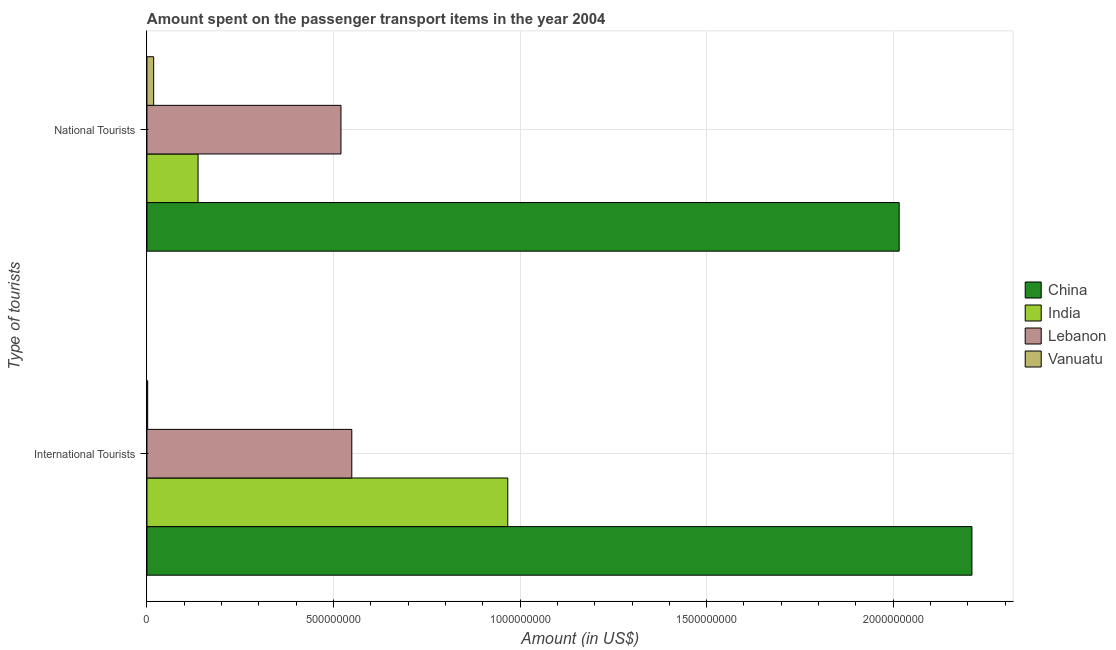How many groups of bars are there?
Ensure brevity in your answer.  2. Are the number of bars on each tick of the Y-axis equal?
Your answer should be compact. Yes. How many bars are there on the 2nd tick from the top?
Give a very brief answer. 4. What is the label of the 1st group of bars from the top?
Your answer should be compact. National Tourists. What is the amount spent on transport items of international tourists in India?
Give a very brief answer. 9.67e+08. Across all countries, what is the maximum amount spent on transport items of national tourists?
Your response must be concise. 2.02e+09. Across all countries, what is the minimum amount spent on transport items of national tourists?
Your answer should be compact. 1.80e+07. In which country was the amount spent on transport items of international tourists maximum?
Your answer should be very brief. China. In which country was the amount spent on transport items of international tourists minimum?
Offer a terse response. Vanuatu. What is the total amount spent on transport items of international tourists in the graph?
Your answer should be compact. 3.73e+09. What is the difference between the amount spent on transport items of national tourists in China and that in Lebanon?
Your answer should be very brief. 1.50e+09. What is the difference between the amount spent on transport items of international tourists in India and the amount spent on transport items of national tourists in Vanuatu?
Keep it short and to the point. 9.49e+08. What is the average amount spent on transport items of national tourists per country?
Your response must be concise. 6.73e+08. What is the difference between the amount spent on transport items of international tourists and amount spent on transport items of national tourists in China?
Provide a succinct answer. 1.95e+08. What is the ratio of the amount spent on transport items of national tourists in Lebanon to that in China?
Give a very brief answer. 0.26. Is the amount spent on transport items of international tourists in Lebanon less than that in India?
Offer a very short reply. Yes. In how many countries, is the amount spent on transport items of national tourists greater than the average amount spent on transport items of national tourists taken over all countries?
Your answer should be very brief. 1. What does the 2nd bar from the top in International Tourists represents?
Give a very brief answer. Lebanon. How many bars are there?
Your answer should be very brief. 8. How many countries are there in the graph?
Your answer should be compact. 4. What is the difference between two consecutive major ticks on the X-axis?
Keep it short and to the point. 5.00e+08. Does the graph contain any zero values?
Ensure brevity in your answer.  No. Does the graph contain grids?
Your answer should be compact. Yes. How many legend labels are there?
Offer a terse response. 4. What is the title of the graph?
Provide a succinct answer. Amount spent on the passenger transport items in the year 2004. What is the label or title of the Y-axis?
Ensure brevity in your answer.  Type of tourists. What is the Amount (in US$) of China in International Tourists?
Make the answer very short. 2.21e+09. What is the Amount (in US$) in India in International Tourists?
Provide a succinct answer. 9.67e+08. What is the Amount (in US$) of Lebanon in International Tourists?
Make the answer very short. 5.49e+08. What is the Amount (in US$) of China in National Tourists?
Your response must be concise. 2.02e+09. What is the Amount (in US$) in India in National Tourists?
Your response must be concise. 1.37e+08. What is the Amount (in US$) in Lebanon in National Tourists?
Provide a short and direct response. 5.20e+08. What is the Amount (in US$) of Vanuatu in National Tourists?
Provide a short and direct response. 1.80e+07. Across all Type of tourists, what is the maximum Amount (in US$) in China?
Provide a succinct answer. 2.21e+09. Across all Type of tourists, what is the maximum Amount (in US$) of India?
Your answer should be compact. 9.67e+08. Across all Type of tourists, what is the maximum Amount (in US$) of Lebanon?
Provide a short and direct response. 5.49e+08. Across all Type of tourists, what is the maximum Amount (in US$) of Vanuatu?
Ensure brevity in your answer.  1.80e+07. Across all Type of tourists, what is the minimum Amount (in US$) in China?
Offer a very short reply. 2.02e+09. Across all Type of tourists, what is the minimum Amount (in US$) in India?
Ensure brevity in your answer.  1.37e+08. Across all Type of tourists, what is the minimum Amount (in US$) of Lebanon?
Give a very brief answer. 5.20e+08. What is the total Amount (in US$) in China in the graph?
Make the answer very short. 4.23e+09. What is the total Amount (in US$) of India in the graph?
Make the answer very short. 1.10e+09. What is the total Amount (in US$) in Lebanon in the graph?
Give a very brief answer. 1.07e+09. What is the total Amount (in US$) of Vanuatu in the graph?
Offer a terse response. 2.00e+07. What is the difference between the Amount (in US$) in China in International Tourists and that in National Tourists?
Your response must be concise. 1.95e+08. What is the difference between the Amount (in US$) of India in International Tourists and that in National Tourists?
Keep it short and to the point. 8.30e+08. What is the difference between the Amount (in US$) of Lebanon in International Tourists and that in National Tourists?
Offer a terse response. 2.90e+07. What is the difference between the Amount (in US$) of Vanuatu in International Tourists and that in National Tourists?
Your answer should be compact. -1.60e+07. What is the difference between the Amount (in US$) in China in International Tourists and the Amount (in US$) in India in National Tourists?
Provide a short and direct response. 2.07e+09. What is the difference between the Amount (in US$) in China in International Tourists and the Amount (in US$) in Lebanon in National Tourists?
Make the answer very short. 1.69e+09. What is the difference between the Amount (in US$) of China in International Tourists and the Amount (in US$) of Vanuatu in National Tourists?
Ensure brevity in your answer.  2.19e+09. What is the difference between the Amount (in US$) of India in International Tourists and the Amount (in US$) of Lebanon in National Tourists?
Provide a succinct answer. 4.47e+08. What is the difference between the Amount (in US$) of India in International Tourists and the Amount (in US$) of Vanuatu in National Tourists?
Your answer should be compact. 9.49e+08. What is the difference between the Amount (in US$) in Lebanon in International Tourists and the Amount (in US$) in Vanuatu in National Tourists?
Offer a terse response. 5.31e+08. What is the average Amount (in US$) of China per Type of tourists?
Keep it short and to the point. 2.11e+09. What is the average Amount (in US$) in India per Type of tourists?
Offer a terse response. 5.52e+08. What is the average Amount (in US$) of Lebanon per Type of tourists?
Give a very brief answer. 5.34e+08. What is the difference between the Amount (in US$) of China and Amount (in US$) of India in International Tourists?
Your answer should be very brief. 1.24e+09. What is the difference between the Amount (in US$) of China and Amount (in US$) of Lebanon in International Tourists?
Offer a terse response. 1.66e+09. What is the difference between the Amount (in US$) in China and Amount (in US$) in Vanuatu in International Tourists?
Offer a terse response. 2.21e+09. What is the difference between the Amount (in US$) of India and Amount (in US$) of Lebanon in International Tourists?
Offer a terse response. 4.18e+08. What is the difference between the Amount (in US$) of India and Amount (in US$) of Vanuatu in International Tourists?
Offer a terse response. 9.65e+08. What is the difference between the Amount (in US$) in Lebanon and Amount (in US$) in Vanuatu in International Tourists?
Ensure brevity in your answer.  5.47e+08. What is the difference between the Amount (in US$) of China and Amount (in US$) of India in National Tourists?
Your answer should be compact. 1.88e+09. What is the difference between the Amount (in US$) of China and Amount (in US$) of Lebanon in National Tourists?
Provide a succinct answer. 1.50e+09. What is the difference between the Amount (in US$) in China and Amount (in US$) in Vanuatu in National Tourists?
Make the answer very short. 2.00e+09. What is the difference between the Amount (in US$) in India and Amount (in US$) in Lebanon in National Tourists?
Your answer should be very brief. -3.83e+08. What is the difference between the Amount (in US$) in India and Amount (in US$) in Vanuatu in National Tourists?
Provide a succinct answer. 1.19e+08. What is the difference between the Amount (in US$) in Lebanon and Amount (in US$) in Vanuatu in National Tourists?
Provide a short and direct response. 5.02e+08. What is the ratio of the Amount (in US$) of China in International Tourists to that in National Tourists?
Keep it short and to the point. 1.1. What is the ratio of the Amount (in US$) of India in International Tourists to that in National Tourists?
Your answer should be very brief. 7.06. What is the ratio of the Amount (in US$) in Lebanon in International Tourists to that in National Tourists?
Give a very brief answer. 1.06. What is the ratio of the Amount (in US$) in Vanuatu in International Tourists to that in National Tourists?
Your answer should be compact. 0.11. What is the difference between the highest and the second highest Amount (in US$) of China?
Give a very brief answer. 1.95e+08. What is the difference between the highest and the second highest Amount (in US$) in India?
Offer a terse response. 8.30e+08. What is the difference between the highest and the second highest Amount (in US$) of Lebanon?
Provide a succinct answer. 2.90e+07. What is the difference between the highest and the second highest Amount (in US$) of Vanuatu?
Make the answer very short. 1.60e+07. What is the difference between the highest and the lowest Amount (in US$) of China?
Offer a very short reply. 1.95e+08. What is the difference between the highest and the lowest Amount (in US$) of India?
Offer a terse response. 8.30e+08. What is the difference between the highest and the lowest Amount (in US$) in Lebanon?
Keep it short and to the point. 2.90e+07. What is the difference between the highest and the lowest Amount (in US$) in Vanuatu?
Your answer should be compact. 1.60e+07. 